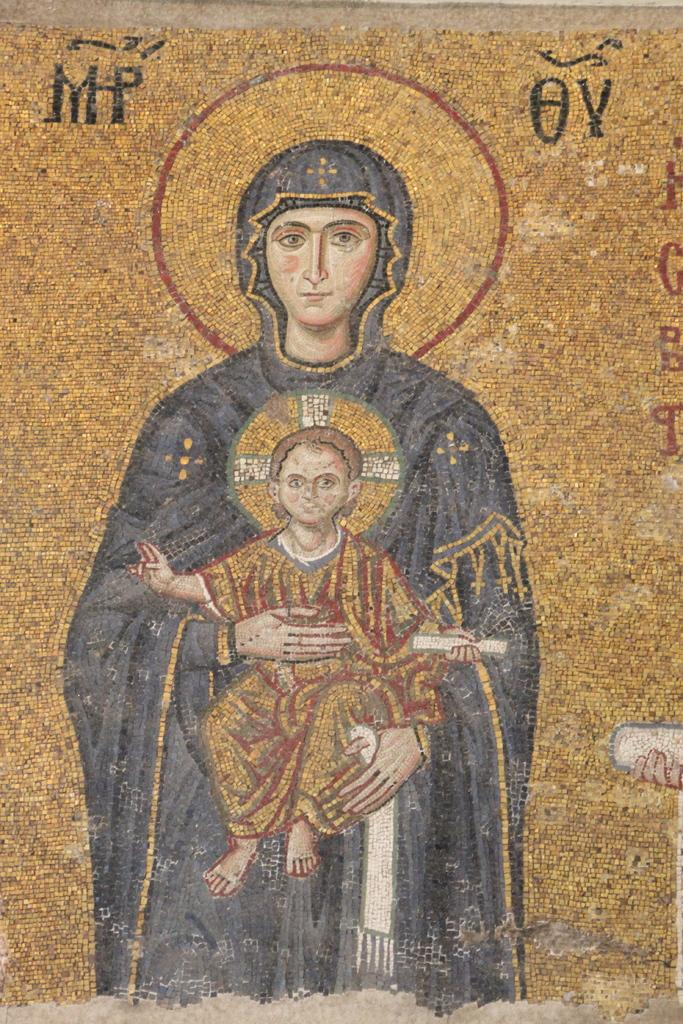What is depicted in the image? There is an art of a woman holding a kid in the image. What colors are used in the art? The art contains blue and cream colors. What is the color of the background in the art? The background of the art is in cream color. How many letters are visible in the art? There are no letters present in the art; it is an image of a woman holding a kid with a blue and cream color scheme. 